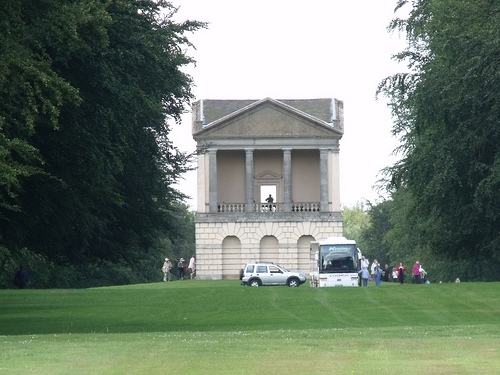<image>
Is the house behind the tree? Yes. From this viewpoint, the house is positioned behind the tree, with the tree partially or fully occluding the house. Is the bus behind the car? No. The bus is not behind the car. From this viewpoint, the bus appears to be positioned elsewhere in the scene. Where is the car in relation to the person? Is it next to the person? Yes. The car is positioned adjacent to the person, located nearby in the same general area. Where is the building in relation to the grass? Is it in front of the grass? No. The building is not in front of the grass. The spatial positioning shows a different relationship between these objects. 